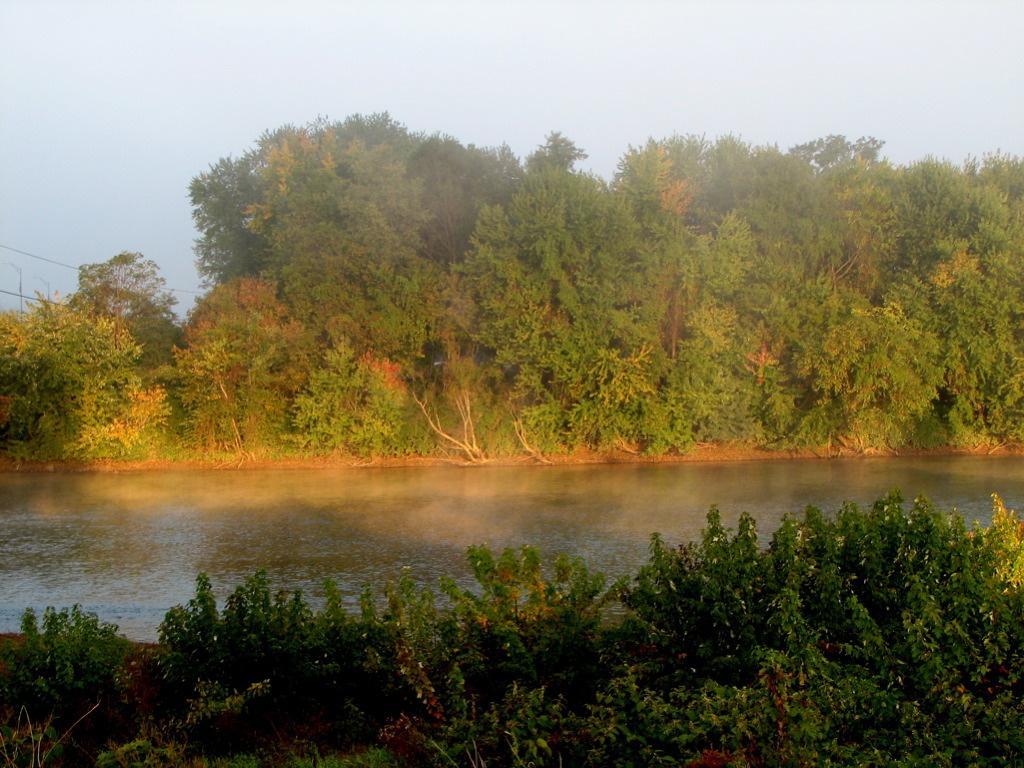Could you give a brief overview of what you see in this image? In this image we can see there is the water and there are trees, plants and the sky. 